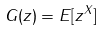Convert formula to latex. <formula><loc_0><loc_0><loc_500><loc_500>G ( z ) = E [ z ^ { X } ]</formula> 